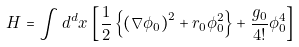<formula> <loc_0><loc_0><loc_500><loc_500>H = \int { d } ^ { d } x \, \left [ \frac { 1 } { 2 } \left \{ \left ( \nabla \phi _ { 0 } \right ) ^ { 2 } + r _ { 0 } \phi _ { 0 } ^ { 2 } \right \} + \frac { g _ { 0 } } { 4 ! } \phi _ { 0 } ^ { 4 } \right ]</formula> 